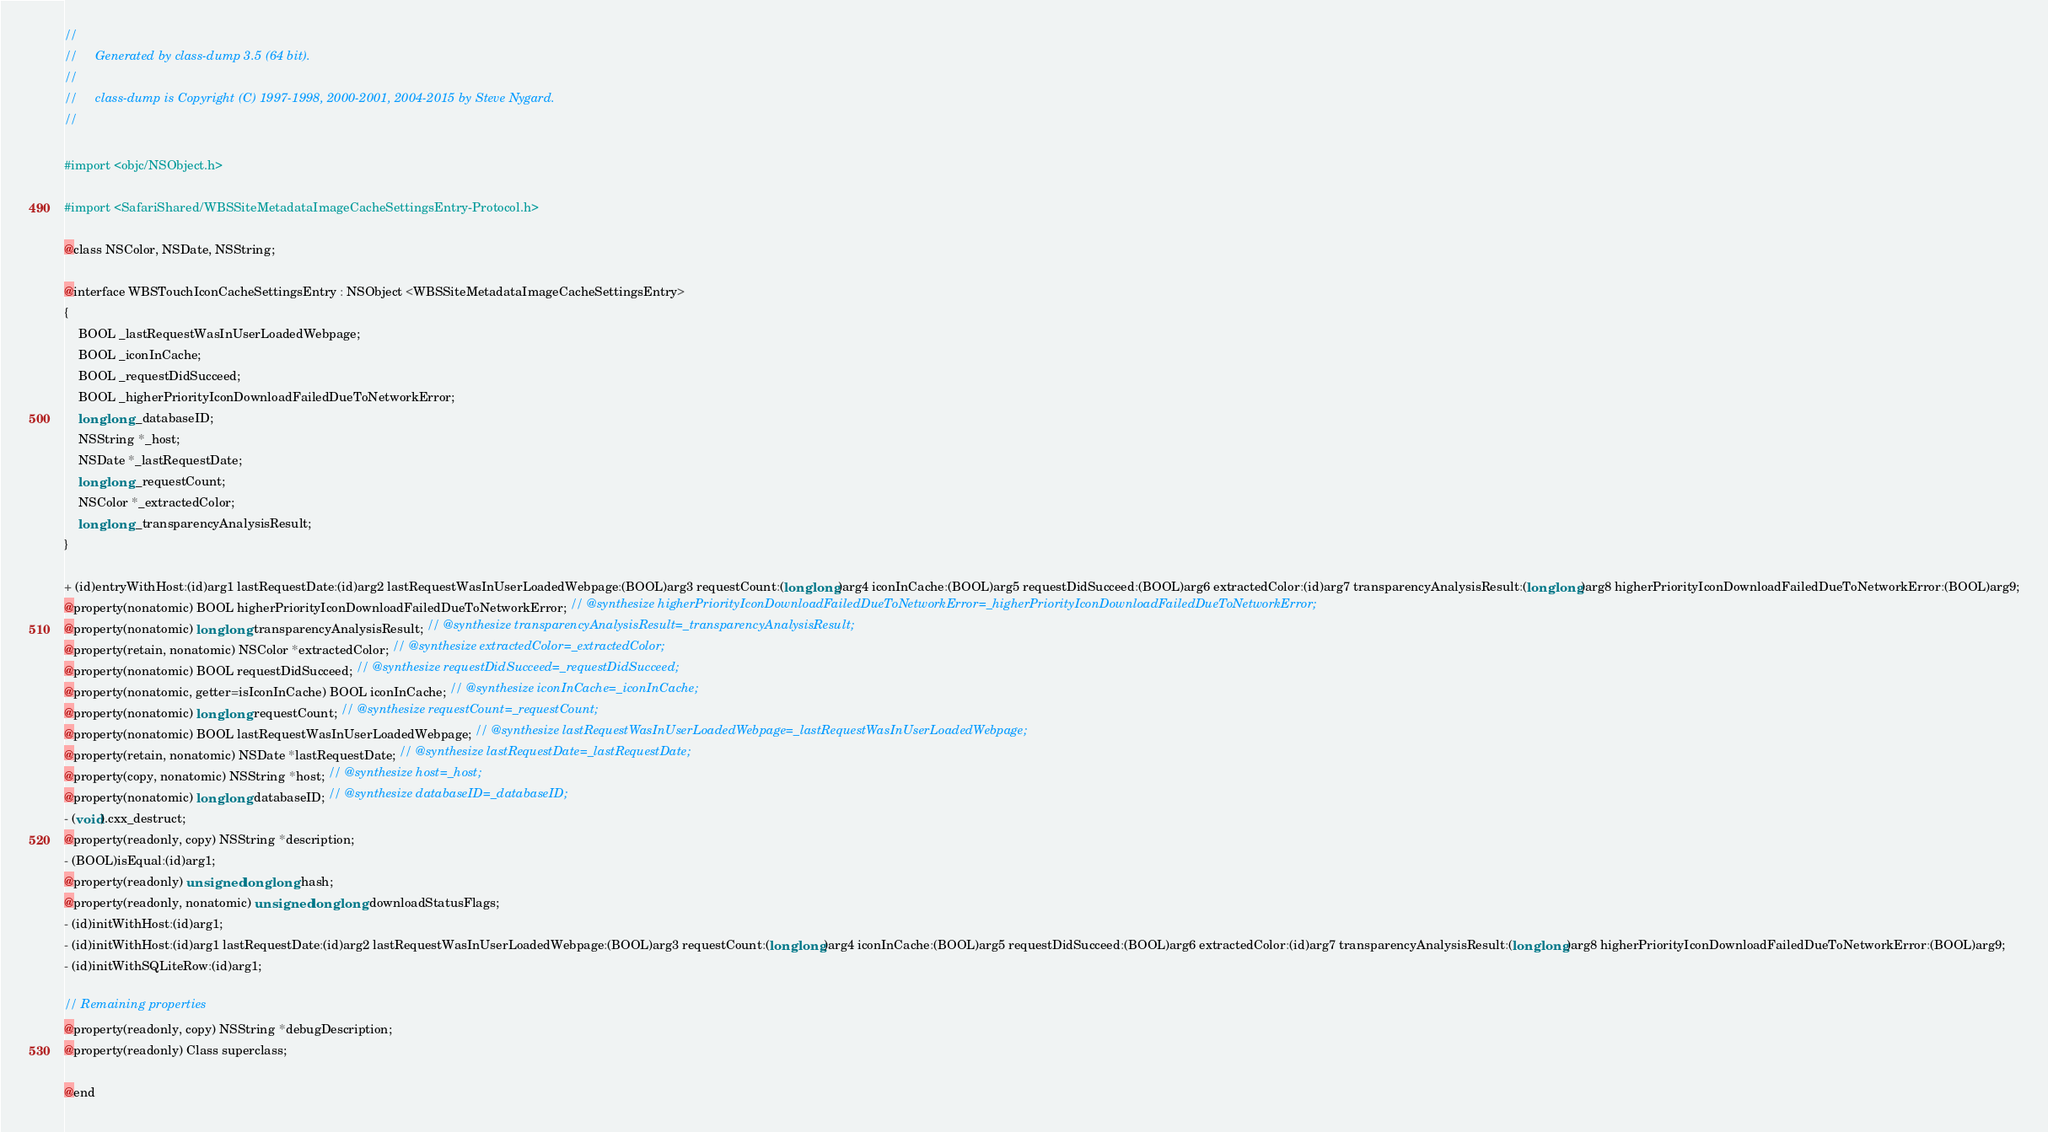Convert code to text. <code><loc_0><loc_0><loc_500><loc_500><_C_>//
//     Generated by class-dump 3.5 (64 bit).
//
//     class-dump is Copyright (C) 1997-1998, 2000-2001, 2004-2015 by Steve Nygard.
//

#import <objc/NSObject.h>

#import <SafariShared/WBSSiteMetadataImageCacheSettingsEntry-Protocol.h>

@class NSColor, NSDate, NSString;

@interface WBSTouchIconCacheSettingsEntry : NSObject <WBSSiteMetadataImageCacheSettingsEntry>
{
    BOOL _lastRequestWasInUserLoadedWebpage;
    BOOL _iconInCache;
    BOOL _requestDidSucceed;
    BOOL _higherPriorityIconDownloadFailedDueToNetworkError;
    long long _databaseID;
    NSString *_host;
    NSDate *_lastRequestDate;
    long long _requestCount;
    NSColor *_extractedColor;
    long long _transparencyAnalysisResult;
}

+ (id)entryWithHost:(id)arg1 lastRequestDate:(id)arg2 lastRequestWasInUserLoadedWebpage:(BOOL)arg3 requestCount:(long long)arg4 iconInCache:(BOOL)arg5 requestDidSucceed:(BOOL)arg6 extractedColor:(id)arg7 transparencyAnalysisResult:(long long)arg8 higherPriorityIconDownloadFailedDueToNetworkError:(BOOL)arg9;
@property(nonatomic) BOOL higherPriorityIconDownloadFailedDueToNetworkError; // @synthesize higherPriorityIconDownloadFailedDueToNetworkError=_higherPriorityIconDownloadFailedDueToNetworkError;
@property(nonatomic) long long transparencyAnalysisResult; // @synthesize transparencyAnalysisResult=_transparencyAnalysisResult;
@property(retain, nonatomic) NSColor *extractedColor; // @synthesize extractedColor=_extractedColor;
@property(nonatomic) BOOL requestDidSucceed; // @synthesize requestDidSucceed=_requestDidSucceed;
@property(nonatomic, getter=isIconInCache) BOOL iconInCache; // @synthesize iconInCache=_iconInCache;
@property(nonatomic) long long requestCount; // @synthesize requestCount=_requestCount;
@property(nonatomic) BOOL lastRequestWasInUserLoadedWebpage; // @synthesize lastRequestWasInUserLoadedWebpage=_lastRequestWasInUserLoadedWebpage;
@property(retain, nonatomic) NSDate *lastRequestDate; // @synthesize lastRequestDate=_lastRequestDate;
@property(copy, nonatomic) NSString *host; // @synthesize host=_host;
@property(nonatomic) long long databaseID; // @synthesize databaseID=_databaseID;
- (void).cxx_destruct;
@property(readonly, copy) NSString *description;
- (BOOL)isEqual:(id)arg1;
@property(readonly) unsigned long long hash;
@property(readonly, nonatomic) unsigned long long downloadStatusFlags;
- (id)initWithHost:(id)arg1;
- (id)initWithHost:(id)arg1 lastRequestDate:(id)arg2 lastRequestWasInUserLoadedWebpage:(BOOL)arg3 requestCount:(long long)arg4 iconInCache:(BOOL)arg5 requestDidSucceed:(BOOL)arg6 extractedColor:(id)arg7 transparencyAnalysisResult:(long long)arg8 higherPriorityIconDownloadFailedDueToNetworkError:(BOOL)arg9;
- (id)initWithSQLiteRow:(id)arg1;

// Remaining properties
@property(readonly, copy) NSString *debugDescription;
@property(readonly) Class superclass;

@end

</code> 